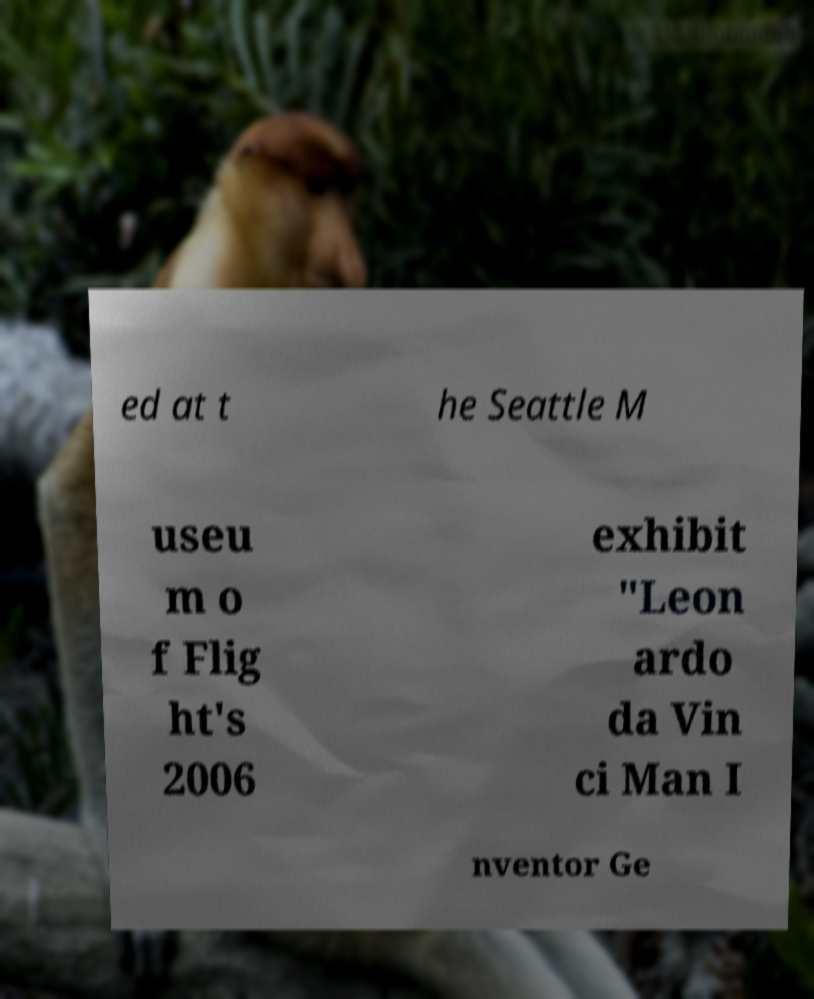Please identify and transcribe the text found in this image. ed at t he Seattle M useu m o f Flig ht's 2006 exhibit "Leon ardo da Vin ci Man I nventor Ge 